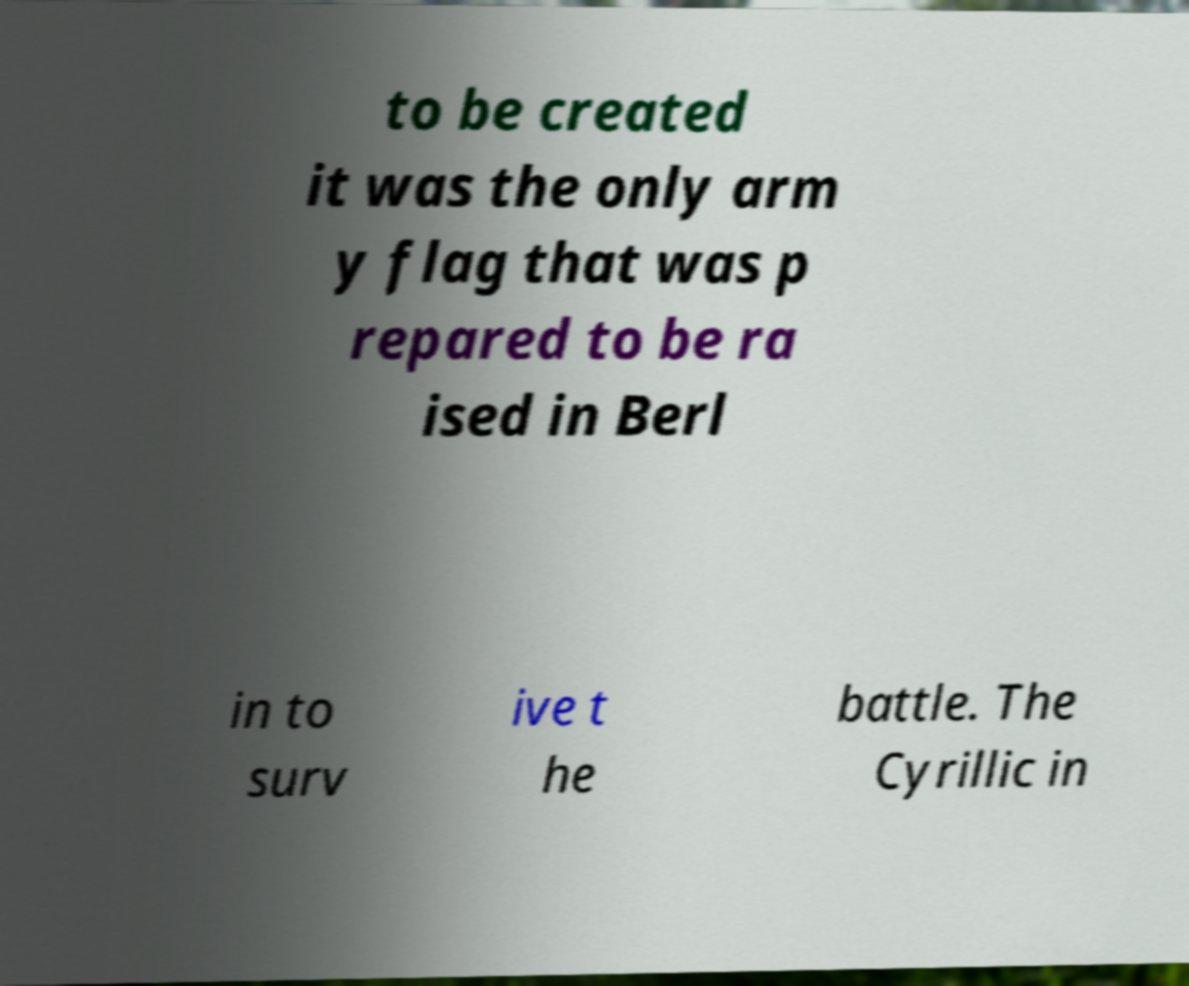Can you read and provide the text displayed in the image?This photo seems to have some interesting text. Can you extract and type it out for me? to be created it was the only arm y flag that was p repared to be ra ised in Berl in to surv ive t he battle. The Cyrillic in 